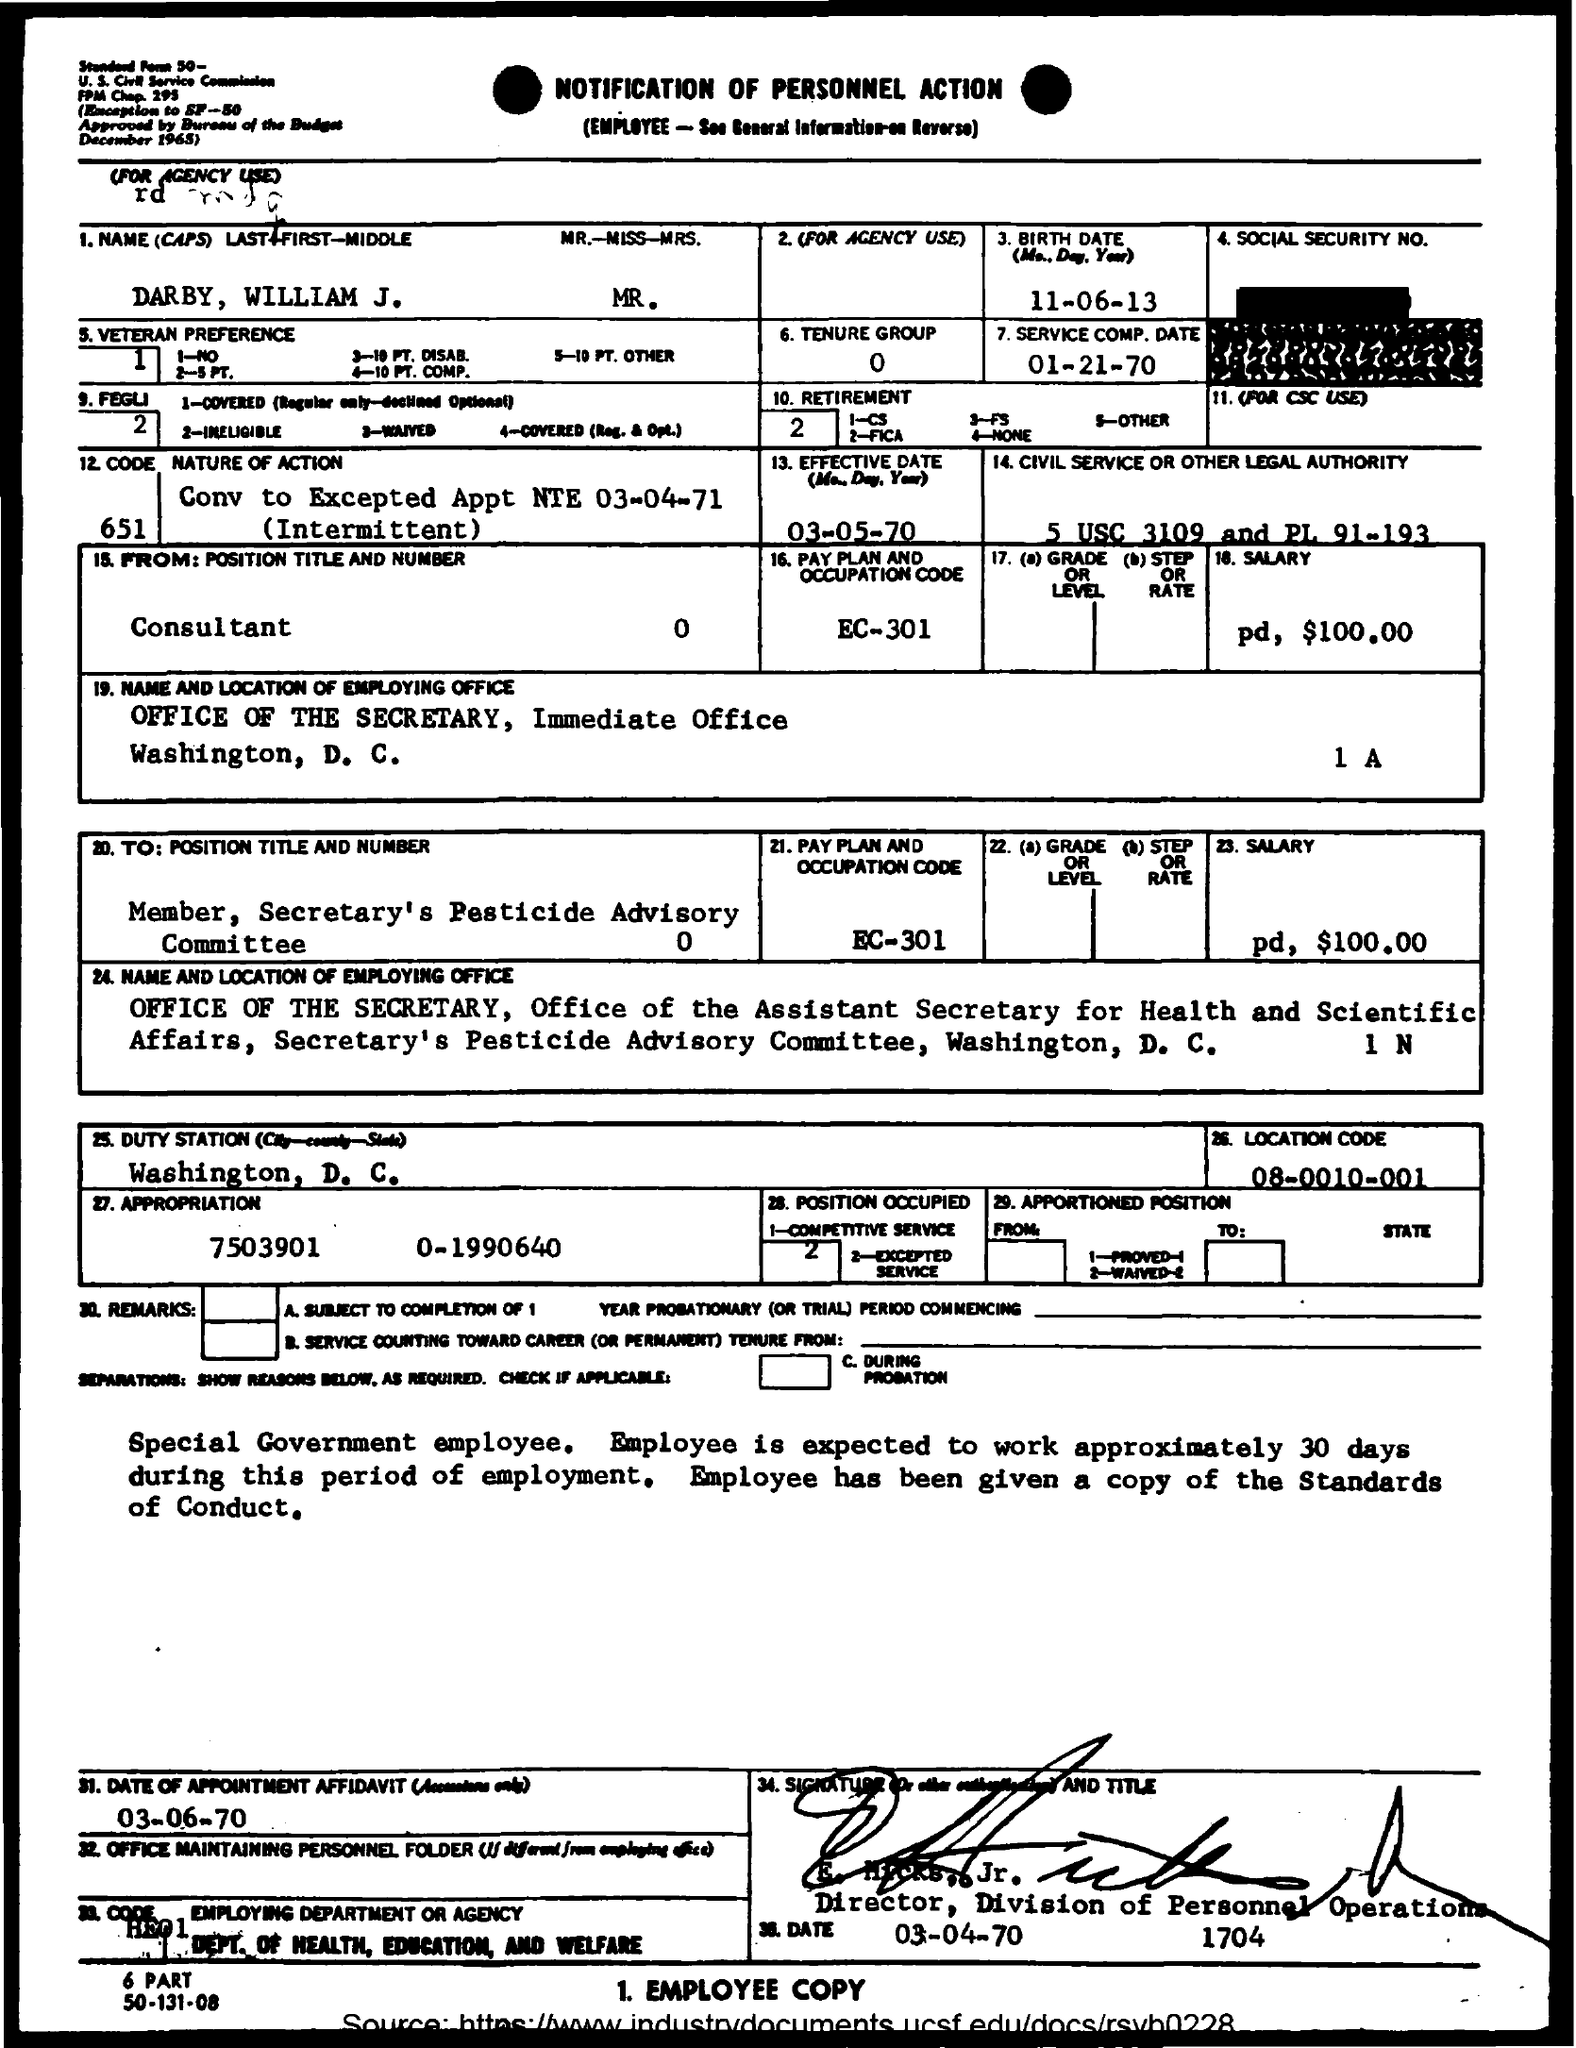Outline some significant characteristics in this image. The location code is 08-0010-001. The birth date mentioned is June 11, 2013. The appropriation is a specific amount of funds, which is 7503901. It has not been allocated or spent yet. It is currently in the range of 0 to 1990640. The salary is $100.00. The location of the office is Washington, D.C. 